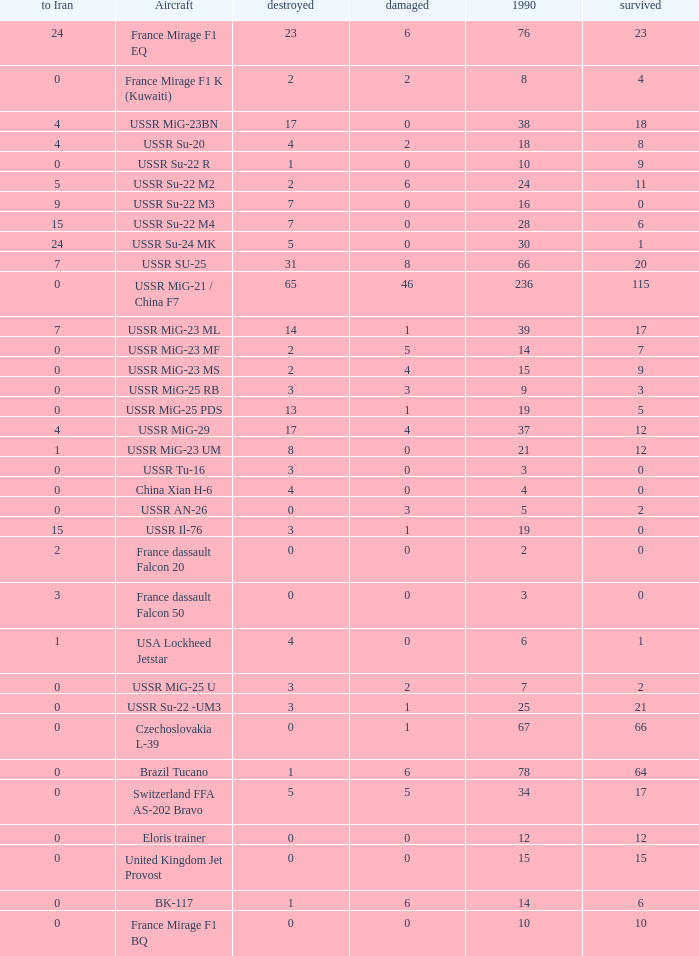If there were 14 in 1990 and 6 survived how many were destroyed? 1.0. 